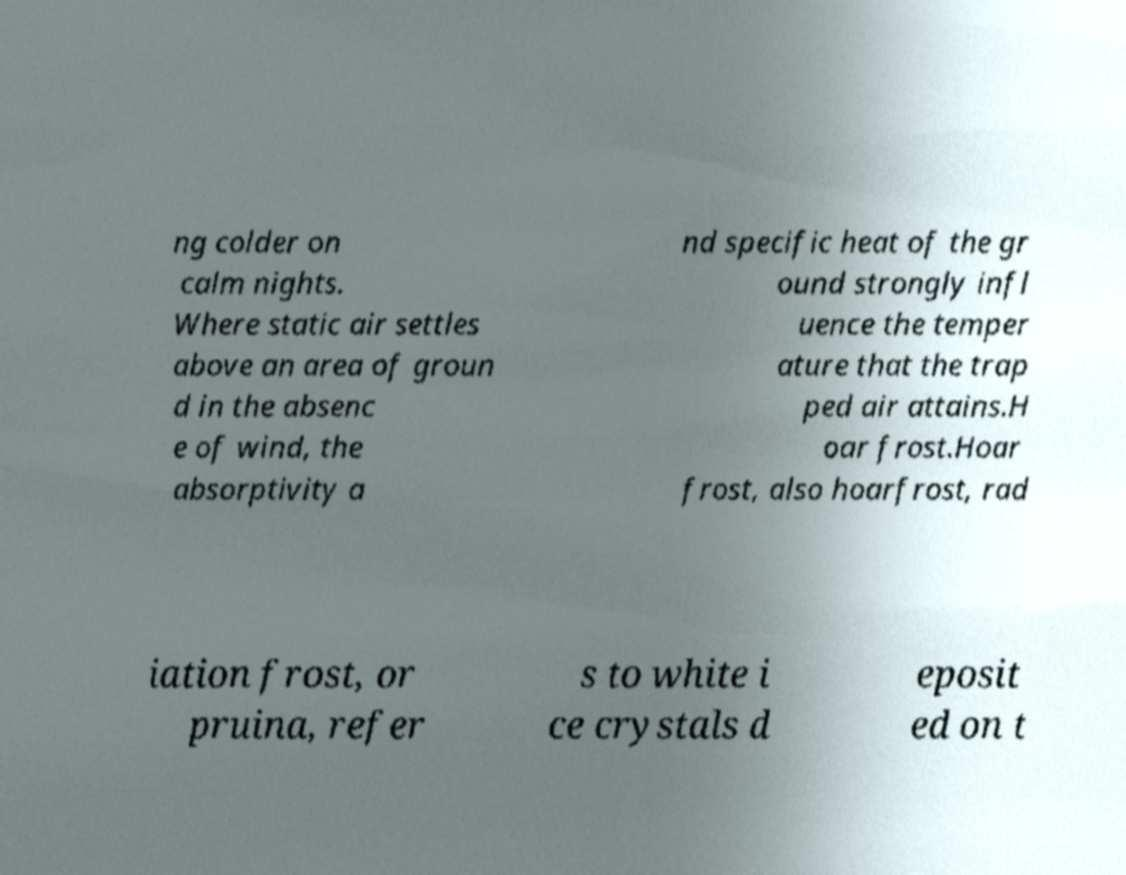I need the written content from this picture converted into text. Can you do that? ng colder on calm nights. Where static air settles above an area of groun d in the absenc e of wind, the absorptivity a nd specific heat of the gr ound strongly infl uence the temper ature that the trap ped air attains.H oar frost.Hoar frost, also hoarfrost, rad iation frost, or pruina, refer s to white i ce crystals d eposit ed on t 